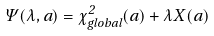<formula> <loc_0><loc_0><loc_500><loc_500>\Psi ( \lambda , a ) = \chi _ { g l o b a l } ^ { 2 } ( a ) + \lambda X ( a )</formula> 